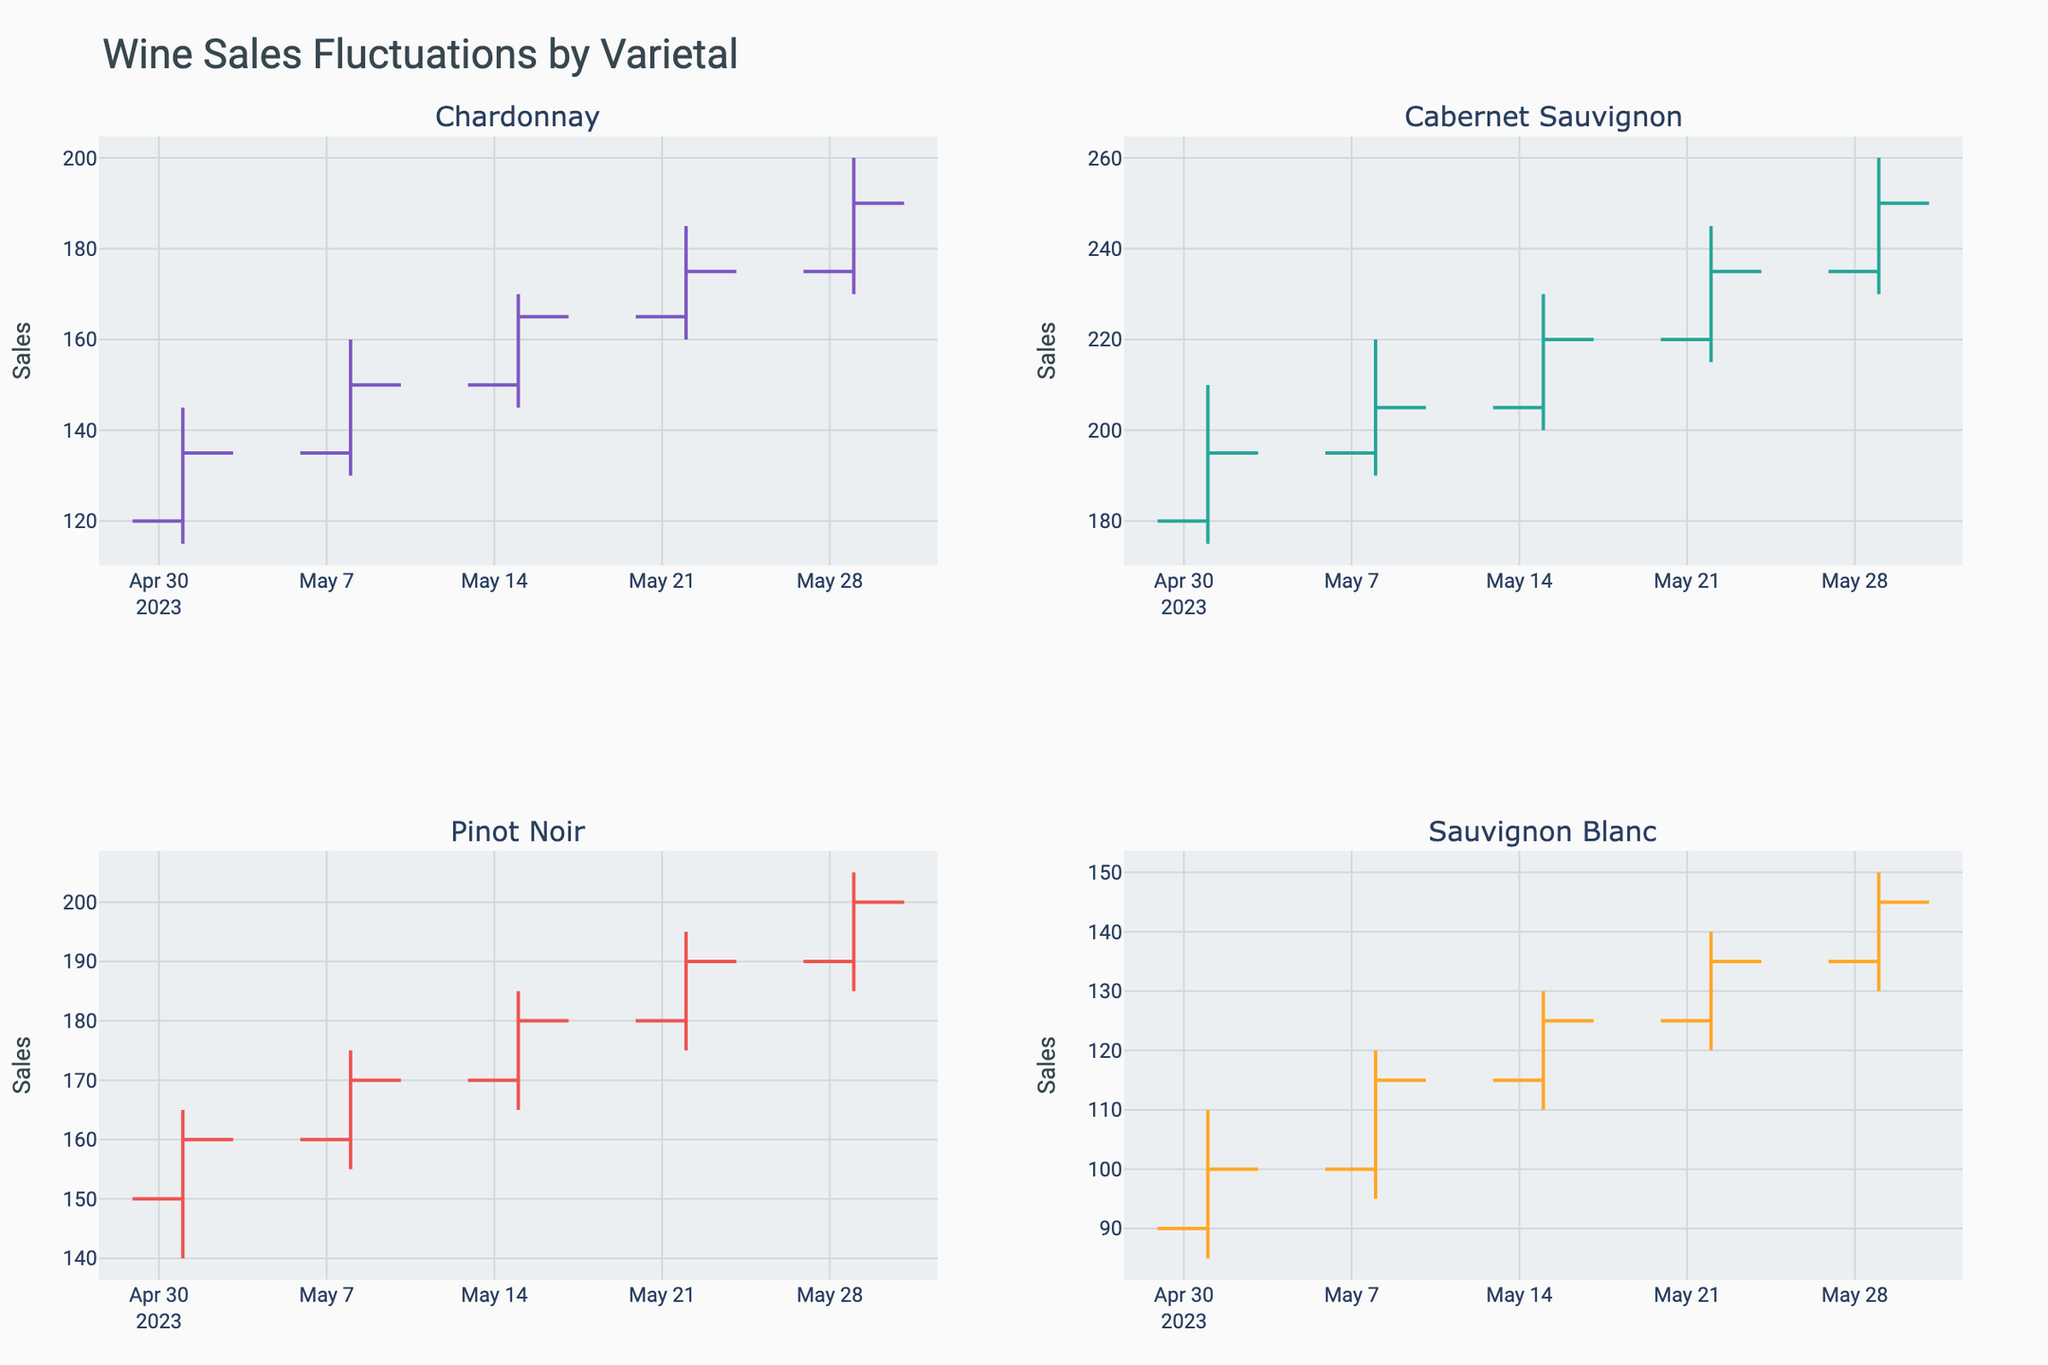What's the title of the figure? The title of the figure can typically be found at the top of the chart, in a larger font, and it summarizes the overall content or theme of the chart.
Answer: Wine Sales Fluctuations by Varietal Which varietal had the highest closing sales value on May 29, 2023? To determine the varietal with the highest closing value on May 29, 2023, look at the closing values in the data for that date and compare them.
Answer: Cabernet Sauvignon What was the average opening sales value for Chardonnay over the month? Calculate the average by summing the opening values for Chardonnay on each date (120 + 135 + 150 + 165 + 175) and dividing by the number of dates.
Answer: 149 On which date did Pinot Noir have its highest high value, and what was that value? By examining the high values for Pinot Noir across all dates, find the maximum high value and note the corresponding date.
Answer: May 29, 205 Between May 1 and May 29, did Sauvignon Blanc have a higher closing value on May 8 or May 15? Compare the closing values of Sauvignon Blanc on May 8 and May 15 by looking at the data for these dates.
Answer: May 15 How many varietals were tracked in this chart? Count the unique varietals listed in the data.
Answer: 4 What is the color used to indicate increasing sales for Chardonnay? Look at the visual representation to identify the color used for increasing sales lines of Chardonnay.
Answer: A shade of purple Compare the lowest low value of Cabernet Sauvignon with that of Sauvignon Blanc over the month. Which varietal had a lower value and what was the value? Identify the lowest low values for both varietals and compare them to determine which one is lower and what the value is.
Answer: Sauvignon Blanc, 85 Which varietal showed the most consistent growth in closing values over the month? Look at the closing values over time for each varietal and determine which one shows a consistent upward trend without major fluctuations.
Answer: Pinot Noir What was the largest drop in closing sales value for any varietal and when did it occur? Look for the largest drop in close values by comparing consecutive dates for each varietal to find the greatest decrease and note the dates involved.
Answer: Chardonnay, from May 1 to May 8 